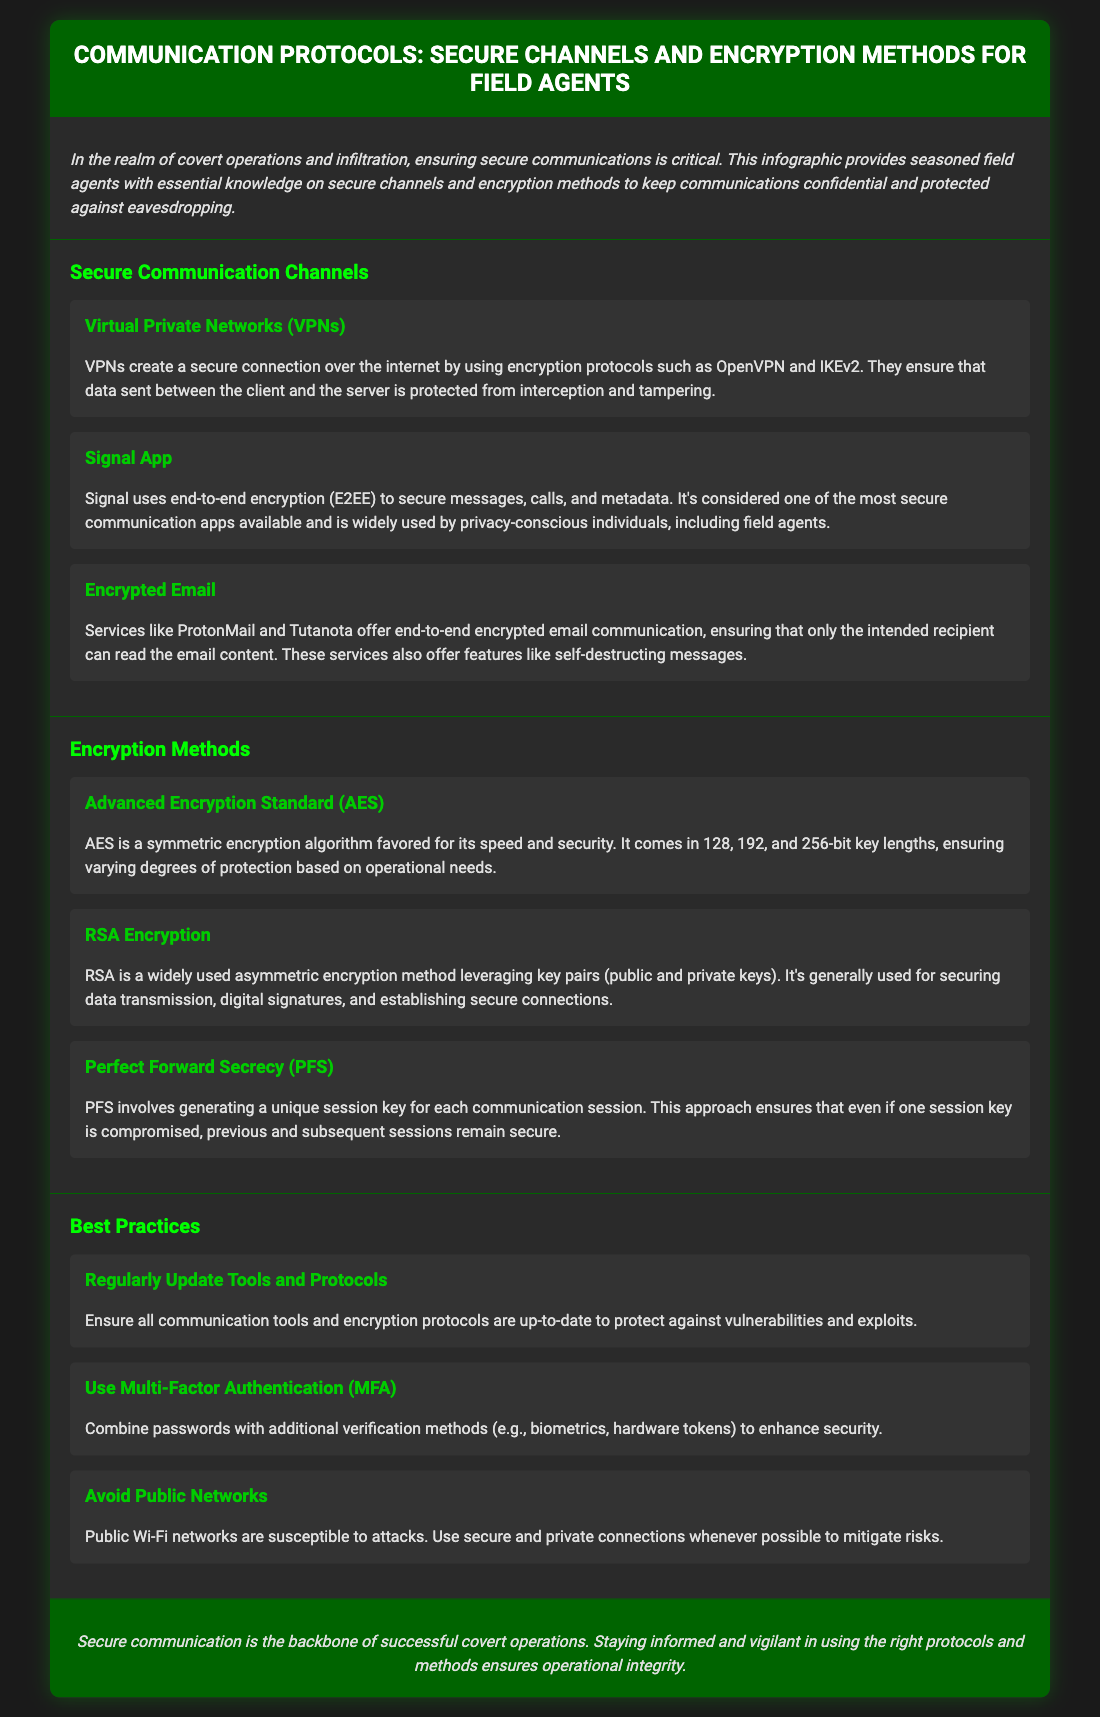what is the title of the infographic? The title of the infographic is provided in the header section, which is "Communication Protocols: Secure Channels and Encryption Methods for Field Agents."
Answer: Communication Protocols: Secure Channels and Encryption Methods for Field Agents what encryption method is favored for speed and security? The document states that the Advanced Encryption Standard (AES) is favored for its speed and security as an encryption method.
Answer: Advanced Encryption Standard (AES) which application is noted for its end-to-end encryption? The document indicates that Signal App uses end-to-end encryption (E2EE) to secure its communications.
Answer: Signal App what is the best practice regarding public networks? The document advises to avoid public networks as they are susceptible to attacks.
Answer: Avoid Public Networks how many types of key lengths does AES have? The document mentions that AES comes in 128, 192, and 256-bit key lengths, denoting three types of key lengths.
Answer: 3 what does PFS stand for? The document mentions Perfect Forward Secrecy, which is abbreviated as PFS.
Answer: Perfect Forward Secrecy what is recommended to enhance security apart from passwords? The document recommends using Multi-Factor Authentication (MFA) in addition to passwords for enhanced security.
Answer: Multi-Factor Authentication (MFA) name one service that offers end-to-end encrypted email. ProtonMail is one of the services mentioned in the document that offers end-to-end encrypted email communication.
Answer: ProtonMail 